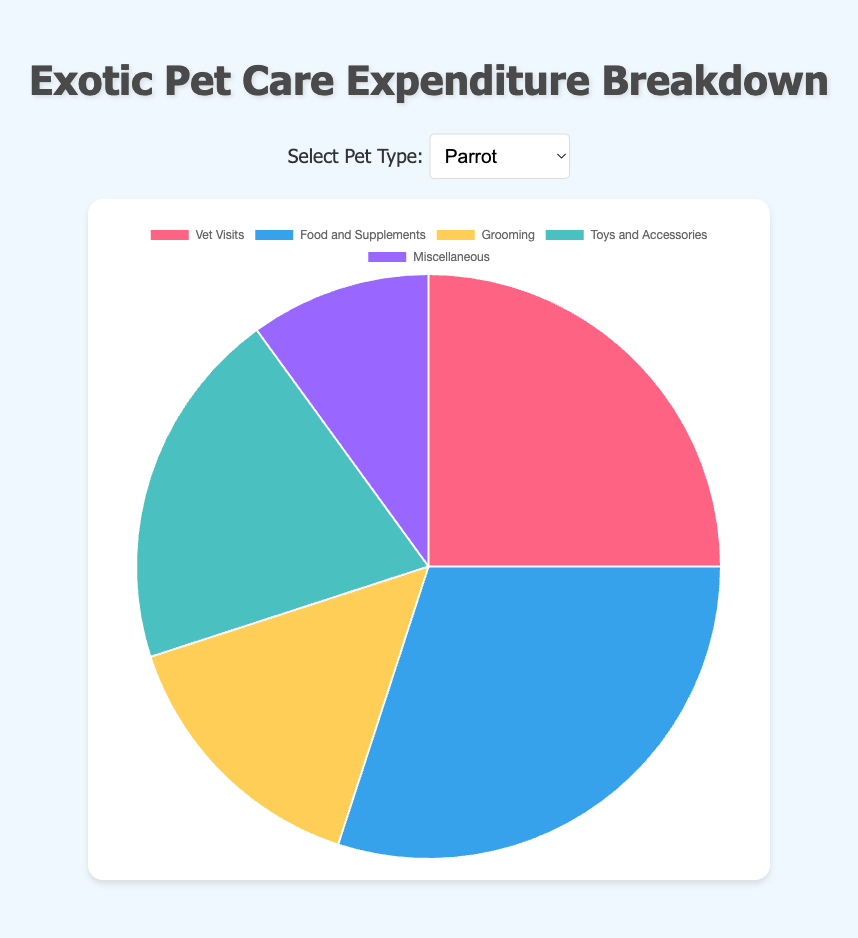What's the largest expenditure category for parrots? The pie chart for parrots shows the breakdown of expenditure by category. The largest segment visually, representing 30%, is for Food and Supplements.
Answer: Food and Supplements Which pet type has the highest percentage dedicated to food and supplements? By comparing the Food and Supplements segments across all pet types in their respective pie charts, Chameleons and Snakes both allocate 40% of their expenditure to this category.
Answer: Chameleon, Snake For snakes, how much more is spent on food and supplements compared to vet visits? In the pie chart for snakes, Food and Supplements take up 40% of the expenditure, while Vet Visits take up 20%. The difference is 40% - 20% = 20%.
Answer: 20% Which pet has a higher percentage allocation to habitat maintenance, turtles or chameleons? The pie charts show Habitat Maintenance for turtles is 30% and for chameleons is also 30%. Therefore, they allocate the same percentage to habitat maintenance.
Answer: Same What is the combined percentage of vet visits and miscellaneous spending for ferrets? For ferrets, the percentage for Vet Visits is 20% and for Miscellaneous is 5%. The combined percentage is 20% + 5% = 25%.
Answer: 25% Which category has the least expenditure for chameleons? The pie chart for chameleons shows the smallest segment, representing 15%, is split between Miscellaneous and Vet Visits.
Answer: Miscellaneous, Vet Visits By what percentage does spending on toys and accessories for ferrets exceed that for parrots? The pie chart indicates Toys and Accessories for ferrets is 25%, while for parrots it is 20%. The percentage difference is 25% - 20% = 5%.
Answer: 5% Among the listed categories, which two have the same expenditure percentage for snakes? The pie chart for snakes displays that both Vet Visits and Miscellaneous are allocated 20% and 15% respectively. Percentages for any two categories are not equal.
Answer: None What is the average percentage expenditure on food and supplements across all pet types? Adding the percentages of Food and Supplements for Parrot (30%), Snake (40%), Turtle (35%), Ferret (30%), and Chameleon (40%) results in a total of 175%. Dividing this by the number of pet types, \( 175 \div 5 = 35% \).
Answer: 35% Is the expenditure on grooming for ferrets higher than any category for turtles? Grooming for ferrets is 20%. All categories for turtles are Vet Visits (15%), Food and Supplements (35%), Habitat Maintenance (30%), and Miscellaneous (20%). Therefore, Grooming for ferrets is higher than Vet Visits for turtles.
Answer: Yes 